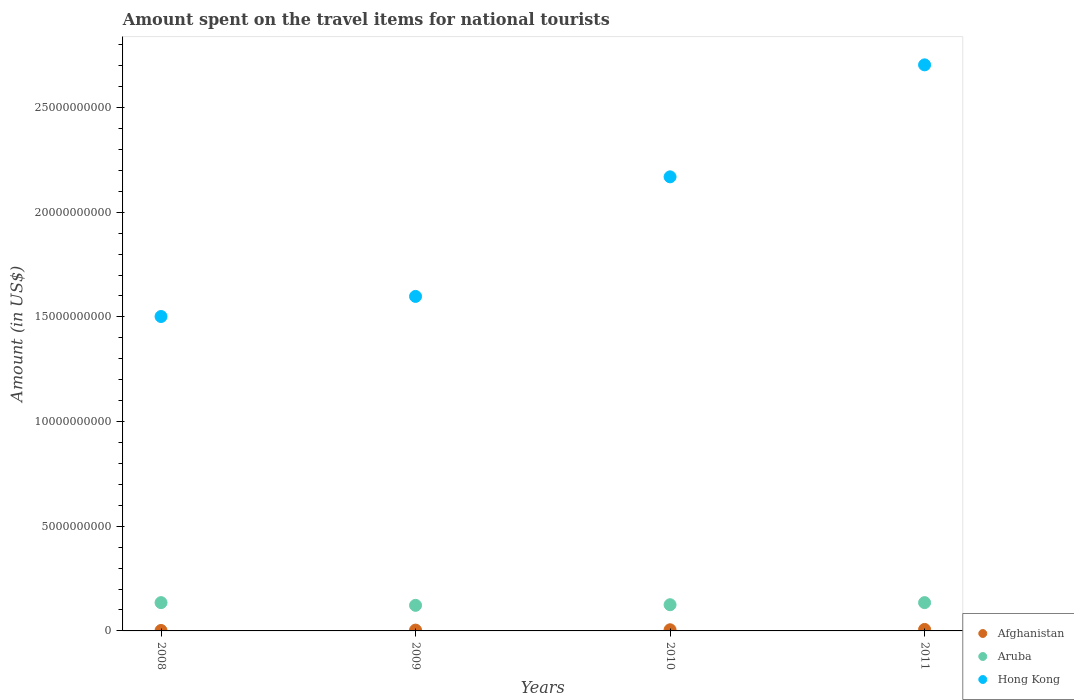How many different coloured dotlines are there?
Make the answer very short. 3. What is the amount spent on the travel items for national tourists in Aruba in 2008?
Your answer should be very brief. 1.35e+09. Across all years, what is the maximum amount spent on the travel items for national tourists in Aruba?
Keep it short and to the point. 1.35e+09. Across all years, what is the minimum amount spent on the travel items for national tourists in Hong Kong?
Keep it short and to the point. 1.50e+1. What is the total amount spent on the travel items for national tourists in Hong Kong in the graph?
Provide a succinct answer. 7.97e+1. What is the difference between the amount spent on the travel items for national tourists in Hong Kong in 2009 and that in 2010?
Give a very brief answer. -5.71e+09. What is the difference between the amount spent on the travel items for national tourists in Aruba in 2011 and the amount spent on the travel items for national tourists in Afghanistan in 2010?
Ensure brevity in your answer.  1.30e+09. What is the average amount spent on the travel items for national tourists in Afghanistan per year?
Offer a very short reply. 4.65e+07. In the year 2009, what is the difference between the amount spent on the travel items for national tourists in Hong Kong and amount spent on the travel items for national tourists in Aruba?
Your answer should be very brief. 1.48e+1. In how many years, is the amount spent on the travel items for national tourists in Aruba greater than 18000000000 US$?
Ensure brevity in your answer.  0. What is the ratio of the amount spent on the travel items for national tourists in Afghanistan in 2009 to that in 2010?
Keep it short and to the point. 0.71. What is the difference between the highest and the second highest amount spent on the travel items for national tourists in Aruba?
Offer a very short reply. 0. In how many years, is the amount spent on the travel items for national tourists in Hong Kong greater than the average amount spent on the travel items for national tourists in Hong Kong taken over all years?
Make the answer very short. 2. Is the sum of the amount spent on the travel items for national tourists in Afghanistan in 2010 and 2011 greater than the maximum amount spent on the travel items for national tourists in Aruba across all years?
Provide a short and direct response. No. Does the amount spent on the travel items for national tourists in Afghanistan monotonically increase over the years?
Give a very brief answer. Yes. Is the amount spent on the travel items for national tourists in Aruba strictly less than the amount spent on the travel items for national tourists in Afghanistan over the years?
Provide a short and direct response. No. How many dotlines are there?
Offer a very short reply. 3. Does the graph contain any zero values?
Keep it short and to the point. No. Does the graph contain grids?
Make the answer very short. No. Where does the legend appear in the graph?
Your response must be concise. Bottom right. How are the legend labels stacked?
Ensure brevity in your answer.  Vertical. What is the title of the graph?
Offer a very short reply. Amount spent on the travel items for national tourists. What is the label or title of the X-axis?
Provide a short and direct response. Years. What is the Amount (in US$) of Afghanistan in 2008?
Offer a terse response. 2.10e+07. What is the Amount (in US$) of Aruba in 2008?
Make the answer very short. 1.35e+09. What is the Amount (in US$) of Hong Kong in 2008?
Your response must be concise. 1.50e+1. What is the Amount (in US$) in Afghanistan in 2009?
Give a very brief answer. 3.90e+07. What is the Amount (in US$) of Aruba in 2009?
Make the answer very short. 1.22e+09. What is the Amount (in US$) in Hong Kong in 2009?
Provide a short and direct response. 1.60e+1. What is the Amount (in US$) in Afghanistan in 2010?
Offer a very short reply. 5.50e+07. What is the Amount (in US$) of Aruba in 2010?
Give a very brief answer. 1.25e+09. What is the Amount (in US$) of Hong Kong in 2010?
Your answer should be compact. 2.17e+1. What is the Amount (in US$) in Afghanistan in 2011?
Your answer should be very brief. 7.10e+07. What is the Amount (in US$) in Aruba in 2011?
Offer a very short reply. 1.35e+09. What is the Amount (in US$) in Hong Kong in 2011?
Ensure brevity in your answer.  2.70e+1. Across all years, what is the maximum Amount (in US$) of Afghanistan?
Your answer should be very brief. 7.10e+07. Across all years, what is the maximum Amount (in US$) in Aruba?
Offer a very short reply. 1.35e+09. Across all years, what is the maximum Amount (in US$) of Hong Kong?
Offer a very short reply. 2.70e+1. Across all years, what is the minimum Amount (in US$) of Afghanistan?
Ensure brevity in your answer.  2.10e+07. Across all years, what is the minimum Amount (in US$) of Aruba?
Ensure brevity in your answer.  1.22e+09. Across all years, what is the minimum Amount (in US$) in Hong Kong?
Offer a very short reply. 1.50e+1. What is the total Amount (in US$) in Afghanistan in the graph?
Keep it short and to the point. 1.86e+08. What is the total Amount (in US$) in Aruba in the graph?
Provide a short and direct response. 5.18e+09. What is the total Amount (in US$) in Hong Kong in the graph?
Your answer should be very brief. 7.97e+1. What is the difference between the Amount (in US$) of Afghanistan in 2008 and that in 2009?
Offer a very short reply. -1.80e+07. What is the difference between the Amount (in US$) of Aruba in 2008 and that in 2009?
Your answer should be very brief. 1.29e+08. What is the difference between the Amount (in US$) of Hong Kong in 2008 and that in 2009?
Give a very brief answer. -9.60e+08. What is the difference between the Amount (in US$) of Afghanistan in 2008 and that in 2010?
Your response must be concise. -3.40e+07. What is the difference between the Amount (in US$) in Aruba in 2008 and that in 2010?
Your response must be concise. 1.00e+08. What is the difference between the Amount (in US$) of Hong Kong in 2008 and that in 2010?
Offer a terse response. -6.67e+09. What is the difference between the Amount (in US$) of Afghanistan in 2008 and that in 2011?
Ensure brevity in your answer.  -5.00e+07. What is the difference between the Amount (in US$) in Aruba in 2008 and that in 2011?
Keep it short and to the point. 0. What is the difference between the Amount (in US$) in Hong Kong in 2008 and that in 2011?
Provide a succinct answer. -1.20e+1. What is the difference between the Amount (in US$) in Afghanistan in 2009 and that in 2010?
Make the answer very short. -1.60e+07. What is the difference between the Amount (in US$) of Aruba in 2009 and that in 2010?
Give a very brief answer. -2.90e+07. What is the difference between the Amount (in US$) in Hong Kong in 2009 and that in 2010?
Make the answer very short. -5.71e+09. What is the difference between the Amount (in US$) in Afghanistan in 2009 and that in 2011?
Offer a very short reply. -3.20e+07. What is the difference between the Amount (in US$) of Aruba in 2009 and that in 2011?
Give a very brief answer. -1.29e+08. What is the difference between the Amount (in US$) in Hong Kong in 2009 and that in 2011?
Your answer should be very brief. -1.11e+1. What is the difference between the Amount (in US$) in Afghanistan in 2010 and that in 2011?
Your answer should be compact. -1.60e+07. What is the difference between the Amount (in US$) of Aruba in 2010 and that in 2011?
Offer a very short reply. -1.00e+08. What is the difference between the Amount (in US$) of Hong Kong in 2010 and that in 2011?
Your response must be concise. -5.35e+09. What is the difference between the Amount (in US$) of Afghanistan in 2008 and the Amount (in US$) of Aruba in 2009?
Make the answer very short. -1.20e+09. What is the difference between the Amount (in US$) in Afghanistan in 2008 and the Amount (in US$) in Hong Kong in 2009?
Keep it short and to the point. -1.60e+1. What is the difference between the Amount (in US$) of Aruba in 2008 and the Amount (in US$) of Hong Kong in 2009?
Give a very brief answer. -1.46e+1. What is the difference between the Amount (in US$) in Afghanistan in 2008 and the Amount (in US$) in Aruba in 2010?
Make the answer very short. -1.23e+09. What is the difference between the Amount (in US$) in Afghanistan in 2008 and the Amount (in US$) in Hong Kong in 2010?
Make the answer very short. -2.17e+1. What is the difference between the Amount (in US$) in Aruba in 2008 and the Amount (in US$) in Hong Kong in 2010?
Your response must be concise. -2.03e+1. What is the difference between the Amount (in US$) in Afghanistan in 2008 and the Amount (in US$) in Aruba in 2011?
Ensure brevity in your answer.  -1.33e+09. What is the difference between the Amount (in US$) in Afghanistan in 2008 and the Amount (in US$) in Hong Kong in 2011?
Make the answer very short. -2.70e+1. What is the difference between the Amount (in US$) in Aruba in 2008 and the Amount (in US$) in Hong Kong in 2011?
Give a very brief answer. -2.57e+1. What is the difference between the Amount (in US$) in Afghanistan in 2009 and the Amount (in US$) in Aruba in 2010?
Offer a terse response. -1.21e+09. What is the difference between the Amount (in US$) in Afghanistan in 2009 and the Amount (in US$) in Hong Kong in 2010?
Offer a very short reply. -2.16e+1. What is the difference between the Amount (in US$) of Aruba in 2009 and the Amount (in US$) of Hong Kong in 2010?
Your response must be concise. -2.05e+1. What is the difference between the Amount (in US$) in Afghanistan in 2009 and the Amount (in US$) in Aruba in 2011?
Make the answer very short. -1.31e+09. What is the difference between the Amount (in US$) of Afghanistan in 2009 and the Amount (in US$) of Hong Kong in 2011?
Keep it short and to the point. -2.70e+1. What is the difference between the Amount (in US$) of Aruba in 2009 and the Amount (in US$) of Hong Kong in 2011?
Make the answer very short. -2.58e+1. What is the difference between the Amount (in US$) of Afghanistan in 2010 and the Amount (in US$) of Aruba in 2011?
Your answer should be very brief. -1.30e+09. What is the difference between the Amount (in US$) of Afghanistan in 2010 and the Amount (in US$) of Hong Kong in 2011?
Ensure brevity in your answer.  -2.70e+1. What is the difference between the Amount (in US$) of Aruba in 2010 and the Amount (in US$) of Hong Kong in 2011?
Offer a very short reply. -2.58e+1. What is the average Amount (in US$) of Afghanistan per year?
Offer a very short reply. 4.65e+07. What is the average Amount (in US$) of Aruba per year?
Make the answer very short. 1.29e+09. What is the average Amount (in US$) in Hong Kong per year?
Provide a short and direct response. 1.99e+1. In the year 2008, what is the difference between the Amount (in US$) in Afghanistan and Amount (in US$) in Aruba?
Make the answer very short. -1.33e+09. In the year 2008, what is the difference between the Amount (in US$) in Afghanistan and Amount (in US$) in Hong Kong?
Make the answer very short. -1.50e+1. In the year 2008, what is the difference between the Amount (in US$) of Aruba and Amount (in US$) of Hong Kong?
Make the answer very short. -1.37e+1. In the year 2009, what is the difference between the Amount (in US$) of Afghanistan and Amount (in US$) of Aruba?
Keep it short and to the point. -1.18e+09. In the year 2009, what is the difference between the Amount (in US$) in Afghanistan and Amount (in US$) in Hong Kong?
Give a very brief answer. -1.59e+1. In the year 2009, what is the difference between the Amount (in US$) in Aruba and Amount (in US$) in Hong Kong?
Offer a very short reply. -1.48e+1. In the year 2010, what is the difference between the Amount (in US$) of Afghanistan and Amount (in US$) of Aruba?
Provide a short and direct response. -1.20e+09. In the year 2010, what is the difference between the Amount (in US$) in Afghanistan and Amount (in US$) in Hong Kong?
Ensure brevity in your answer.  -2.16e+1. In the year 2010, what is the difference between the Amount (in US$) in Aruba and Amount (in US$) in Hong Kong?
Ensure brevity in your answer.  -2.04e+1. In the year 2011, what is the difference between the Amount (in US$) of Afghanistan and Amount (in US$) of Aruba?
Keep it short and to the point. -1.28e+09. In the year 2011, what is the difference between the Amount (in US$) of Afghanistan and Amount (in US$) of Hong Kong?
Offer a terse response. -2.70e+1. In the year 2011, what is the difference between the Amount (in US$) of Aruba and Amount (in US$) of Hong Kong?
Ensure brevity in your answer.  -2.57e+1. What is the ratio of the Amount (in US$) in Afghanistan in 2008 to that in 2009?
Provide a short and direct response. 0.54. What is the ratio of the Amount (in US$) in Aruba in 2008 to that in 2009?
Your response must be concise. 1.11. What is the ratio of the Amount (in US$) in Hong Kong in 2008 to that in 2009?
Your answer should be compact. 0.94. What is the ratio of the Amount (in US$) of Afghanistan in 2008 to that in 2010?
Your response must be concise. 0.38. What is the ratio of the Amount (in US$) of Aruba in 2008 to that in 2010?
Offer a very short reply. 1.08. What is the ratio of the Amount (in US$) in Hong Kong in 2008 to that in 2010?
Ensure brevity in your answer.  0.69. What is the ratio of the Amount (in US$) of Afghanistan in 2008 to that in 2011?
Provide a short and direct response. 0.3. What is the ratio of the Amount (in US$) of Aruba in 2008 to that in 2011?
Make the answer very short. 1. What is the ratio of the Amount (in US$) of Hong Kong in 2008 to that in 2011?
Your answer should be very brief. 0.56. What is the ratio of the Amount (in US$) in Afghanistan in 2009 to that in 2010?
Provide a succinct answer. 0.71. What is the ratio of the Amount (in US$) in Aruba in 2009 to that in 2010?
Provide a short and direct response. 0.98. What is the ratio of the Amount (in US$) of Hong Kong in 2009 to that in 2010?
Give a very brief answer. 0.74. What is the ratio of the Amount (in US$) in Afghanistan in 2009 to that in 2011?
Ensure brevity in your answer.  0.55. What is the ratio of the Amount (in US$) of Aruba in 2009 to that in 2011?
Provide a short and direct response. 0.9. What is the ratio of the Amount (in US$) in Hong Kong in 2009 to that in 2011?
Your response must be concise. 0.59. What is the ratio of the Amount (in US$) in Afghanistan in 2010 to that in 2011?
Your answer should be compact. 0.77. What is the ratio of the Amount (in US$) of Aruba in 2010 to that in 2011?
Offer a very short reply. 0.93. What is the ratio of the Amount (in US$) in Hong Kong in 2010 to that in 2011?
Your response must be concise. 0.8. What is the difference between the highest and the second highest Amount (in US$) of Afghanistan?
Make the answer very short. 1.60e+07. What is the difference between the highest and the second highest Amount (in US$) of Aruba?
Make the answer very short. 0. What is the difference between the highest and the second highest Amount (in US$) in Hong Kong?
Give a very brief answer. 5.35e+09. What is the difference between the highest and the lowest Amount (in US$) in Aruba?
Make the answer very short. 1.29e+08. What is the difference between the highest and the lowest Amount (in US$) in Hong Kong?
Provide a short and direct response. 1.20e+1. 